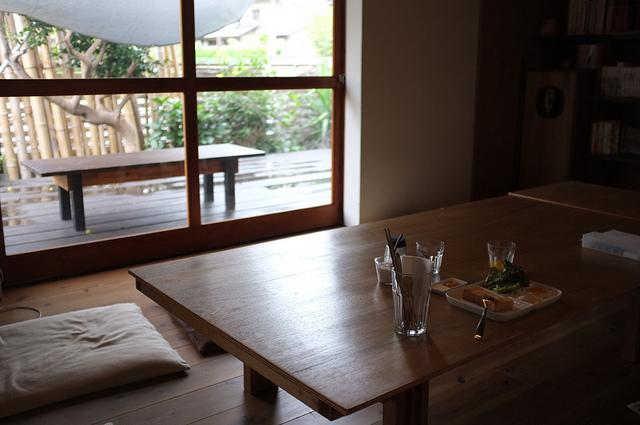What is closest to the left ledge of the table?

Choices:
A) pumpkin
B) orange
C) tray
D) glass glass 